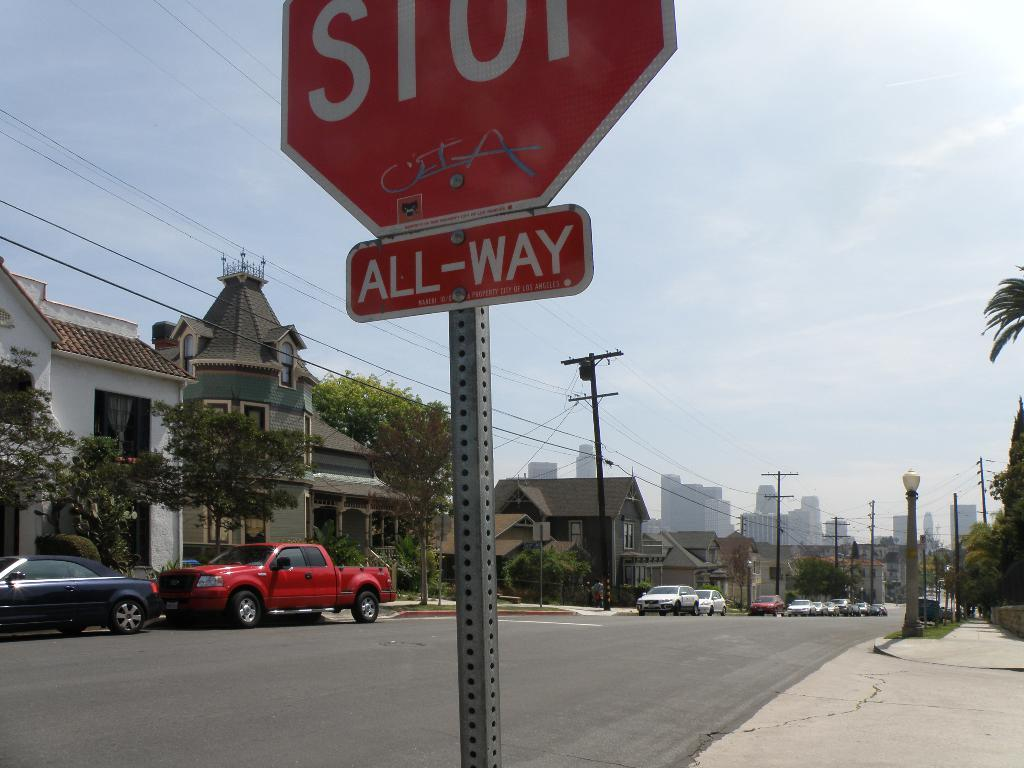<image>
Create a compact narrative representing the image presented. a STOP sign with an All-Way sign overlooking a residential street 